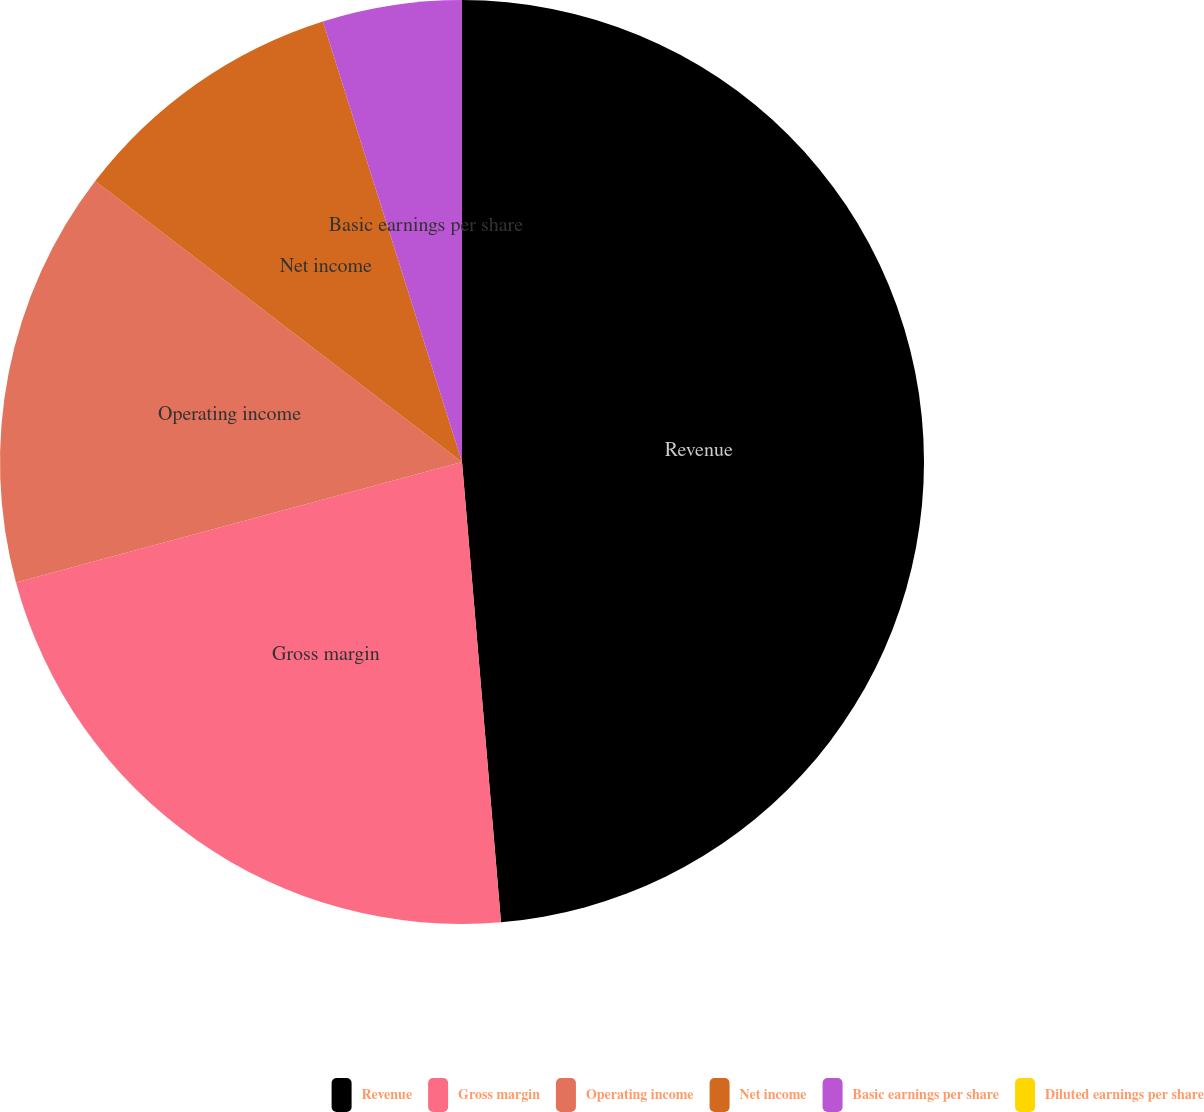Convert chart to OTSL. <chart><loc_0><loc_0><loc_500><loc_500><pie_chart><fcel>Revenue<fcel>Gross margin<fcel>Operating income<fcel>Net income<fcel>Basic earnings per share<fcel>Diluted earnings per share<nl><fcel>48.66%<fcel>22.15%<fcel>14.6%<fcel>9.73%<fcel>4.87%<fcel>0.0%<nl></chart> 